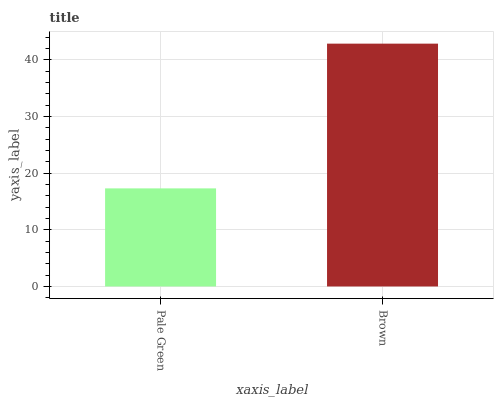Is Pale Green the minimum?
Answer yes or no. Yes. Is Brown the maximum?
Answer yes or no. Yes. Is Brown the minimum?
Answer yes or no. No. Is Brown greater than Pale Green?
Answer yes or no. Yes. Is Pale Green less than Brown?
Answer yes or no. Yes. Is Pale Green greater than Brown?
Answer yes or no. No. Is Brown less than Pale Green?
Answer yes or no. No. Is Brown the high median?
Answer yes or no. Yes. Is Pale Green the low median?
Answer yes or no. Yes. Is Pale Green the high median?
Answer yes or no. No. Is Brown the low median?
Answer yes or no. No. 